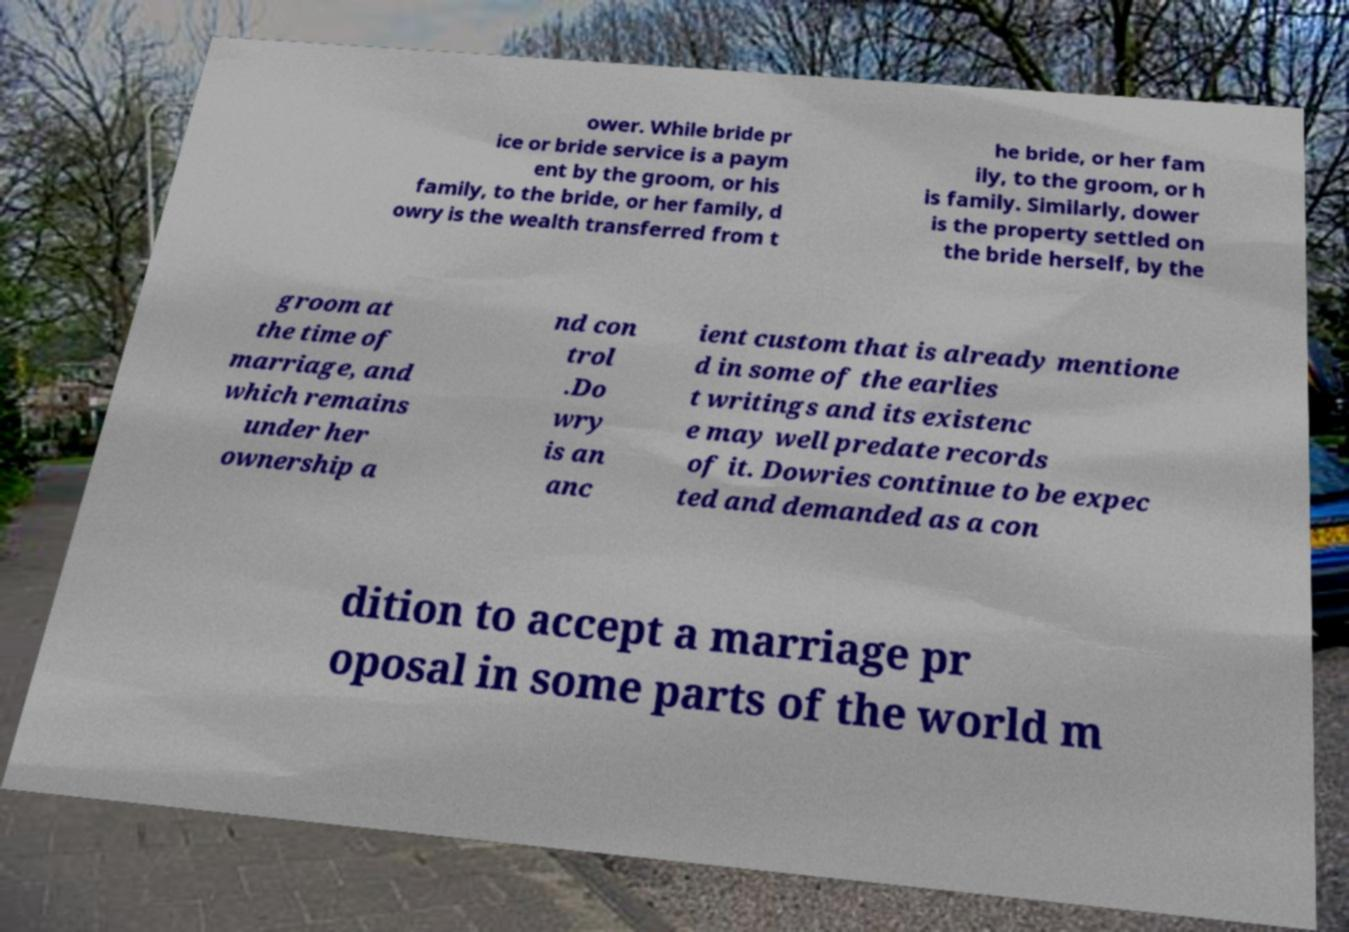What messages or text are displayed in this image? I need them in a readable, typed format. ower. While bride pr ice or bride service is a paym ent by the groom, or his family, to the bride, or her family, d owry is the wealth transferred from t he bride, or her fam ily, to the groom, or h is family. Similarly, dower is the property settled on the bride herself, by the groom at the time of marriage, and which remains under her ownership a nd con trol .Do wry is an anc ient custom that is already mentione d in some of the earlies t writings and its existenc e may well predate records of it. Dowries continue to be expec ted and demanded as a con dition to accept a marriage pr oposal in some parts of the world m 